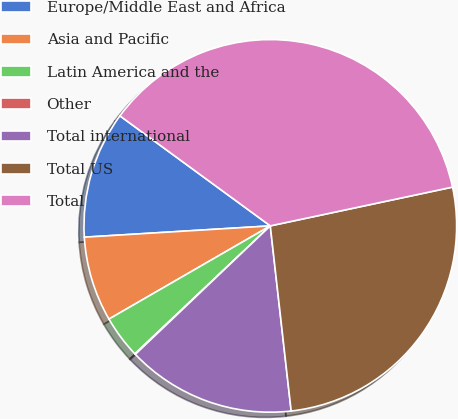<chart> <loc_0><loc_0><loc_500><loc_500><pie_chart><fcel>Europe/Middle East and Africa<fcel>Asia and Pacific<fcel>Latin America and the<fcel>Other<fcel>Total international<fcel>Total US<fcel>Total<nl><fcel>11.02%<fcel>7.37%<fcel>3.71%<fcel>0.06%<fcel>14.68%<fcel>26.55%<fcel>36.61%<nl></chart> 